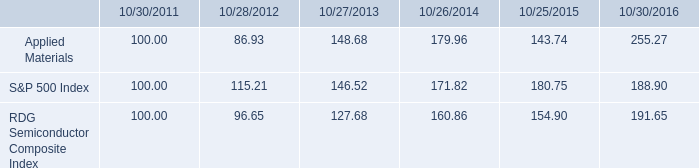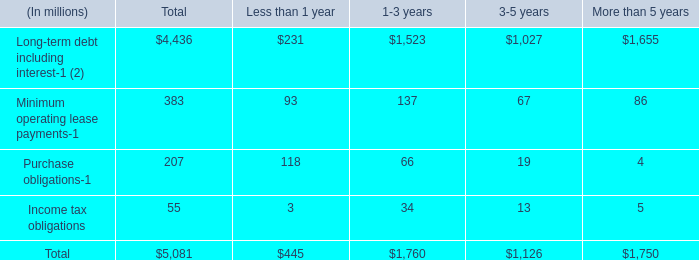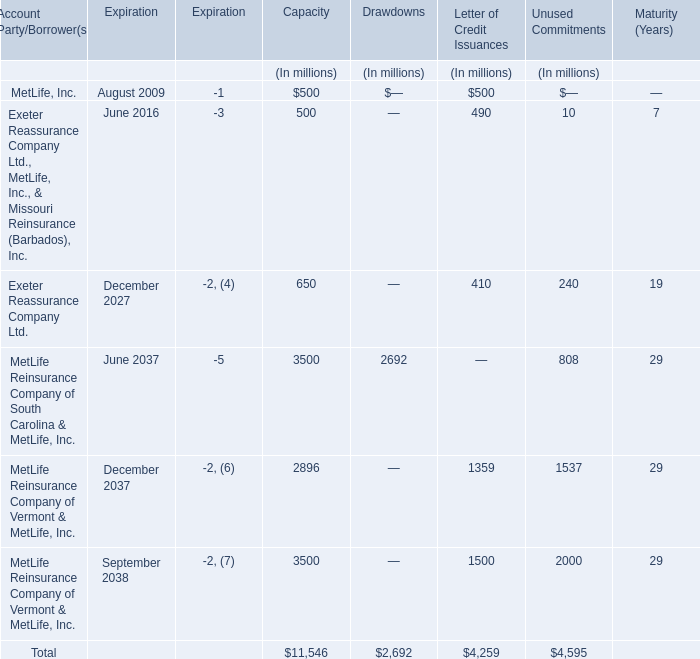What is the percentage of MetLife, Inc. in relation to the total for Letter of Credit Issuances ? 
Computations: (500 / 4259)
Answer: 0.1174. 